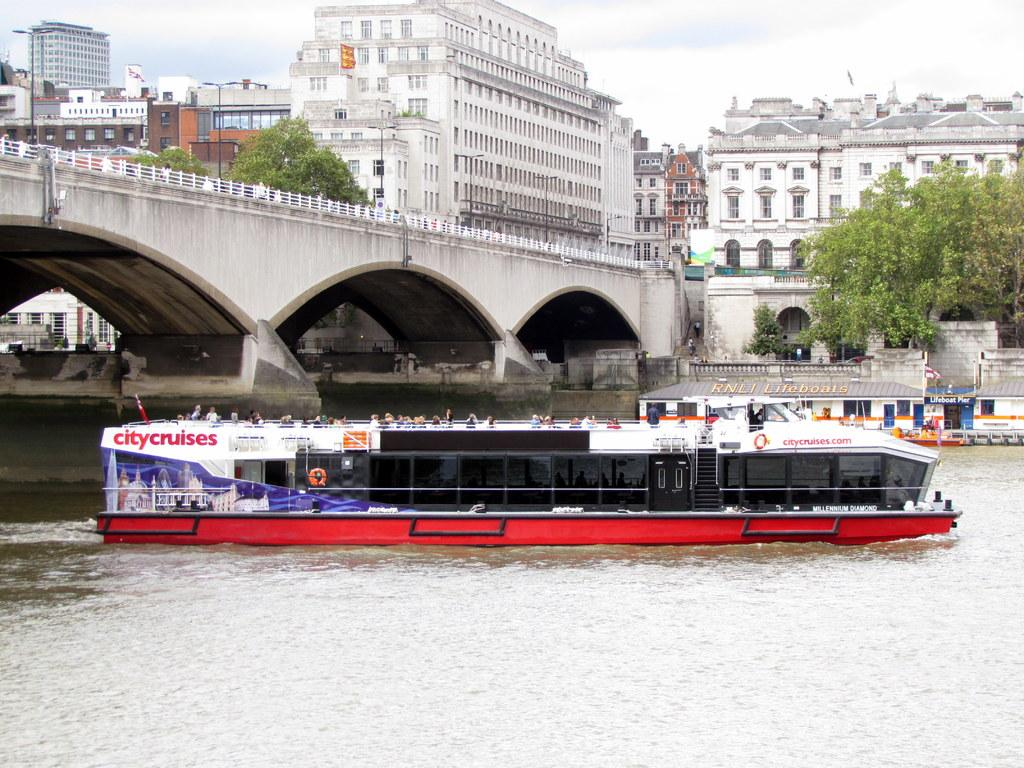What is the main subject of the image? The main subject of the image is a boat. What is the boat's location in the image? The boat is on the water. What can be seen behind the boat? There is a bridge, trees, poles, buildings, and the sky visible in the background. What type of net is being used to catch fish in the image? There is no net present in the image, and no fishing activity is depicted. 